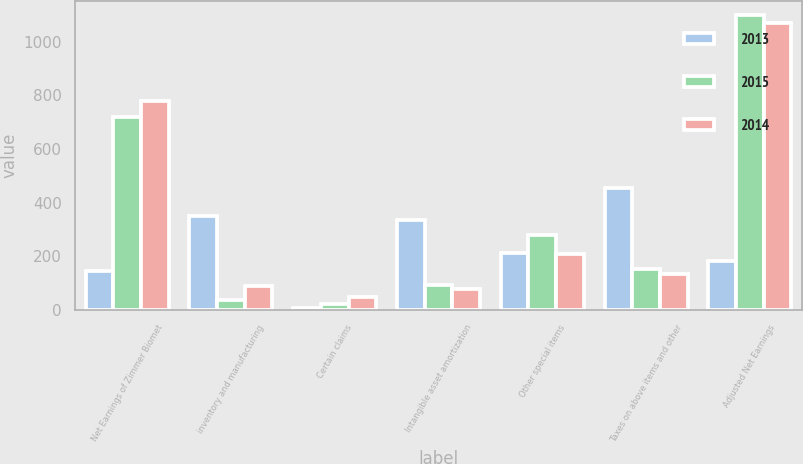Convert chart. <chart><loc_0><loc_0><loc_500><loc_500><stacked_bar_chart><ecel><fcel>Net Earnings of Zimmer Biomet<fcel>inventory and manufacturing<fcel>Certain claims<fcel>Intangible asset amortization<fcel>Other special items<fcel>Taxes on above items and other<fcel>Adjusted Net Earnings<nl><fcel>2013<fcel>147<fcel>348.8<fcel>7.7<fcel>337.4<fcel>212.7<fcel>455.2<fcel>181.8<nl><fcel>2015<fcel>720.3<fcel>36.3<fcel>21.5<fcel>92.5<fcel>279.2<fcel>153.3<fcel>1098<nl><fcel>2014<fcel>780.4<fcel>88.7<fcel>47<fcel>78.5<fcel>210.3<fcel>135.9<fcel>1069<nl></chart> 